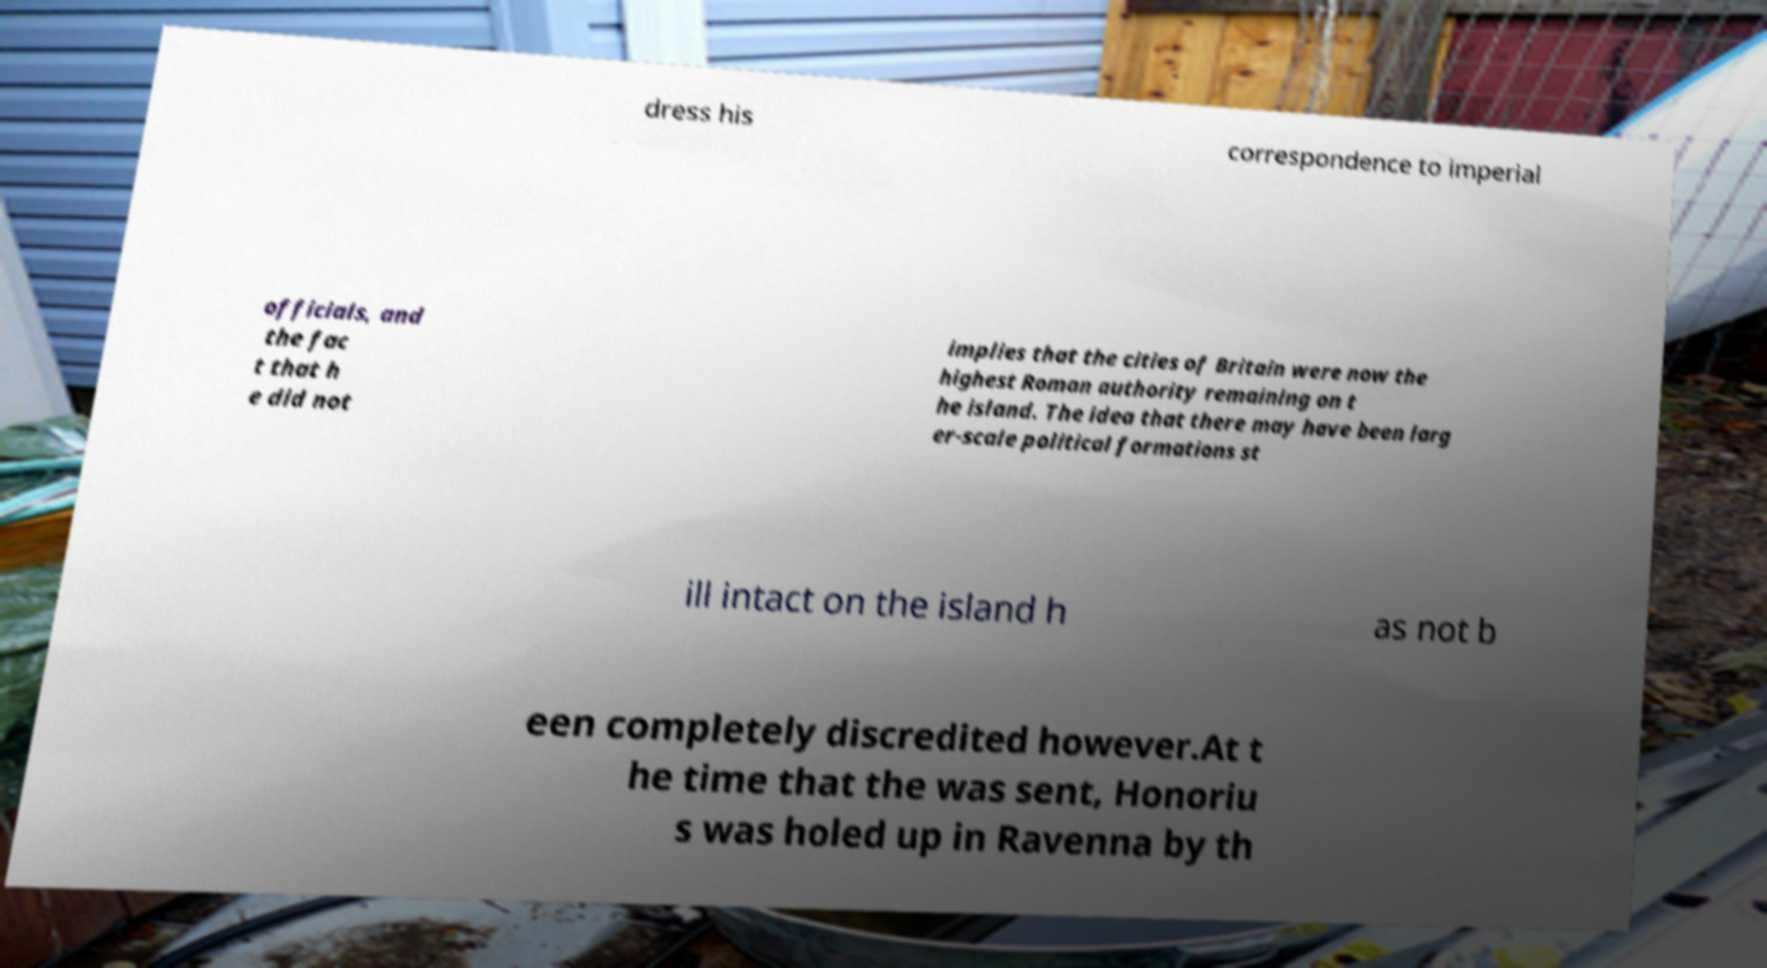Could you assist in decoding the text presented in this image and type it out clearly? dress his correspondence to imperial officials, and the fac t that h e did not implies that the cities of Britain were now the highest Roman authority remaining on t he island. The idea that there may have been larg er-scale political formations st ill intact on the island h as not b een completely discredited however.At t he time that the was sent, Honoriu s was holed up in Ravenna by th 